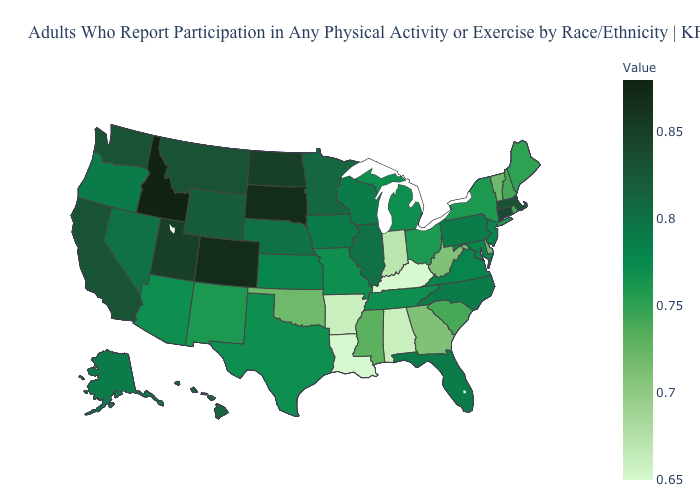Which states have the highest value in the USA?
Quick response, please. Idaho. Among the states that border Iowa , does Missouri have the lowest value?
Answer briefly. Yes. Which states have the lowest value in the West?
Answer briefly. New Mexico. Does Washington have the lowest value in the USA?
Quick response, please. No. 